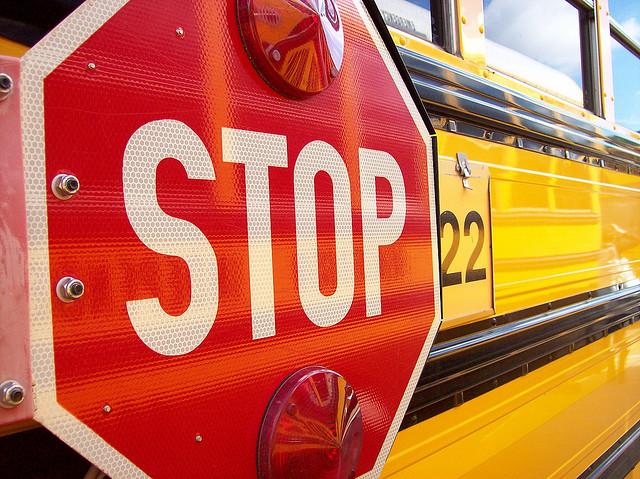What is the number of the bus?
Keep it brief. 22. What is in the reflection of the stop sign?
Give a very brief answer. School bus. What color is the bus?
Short answer required. Yellow. 